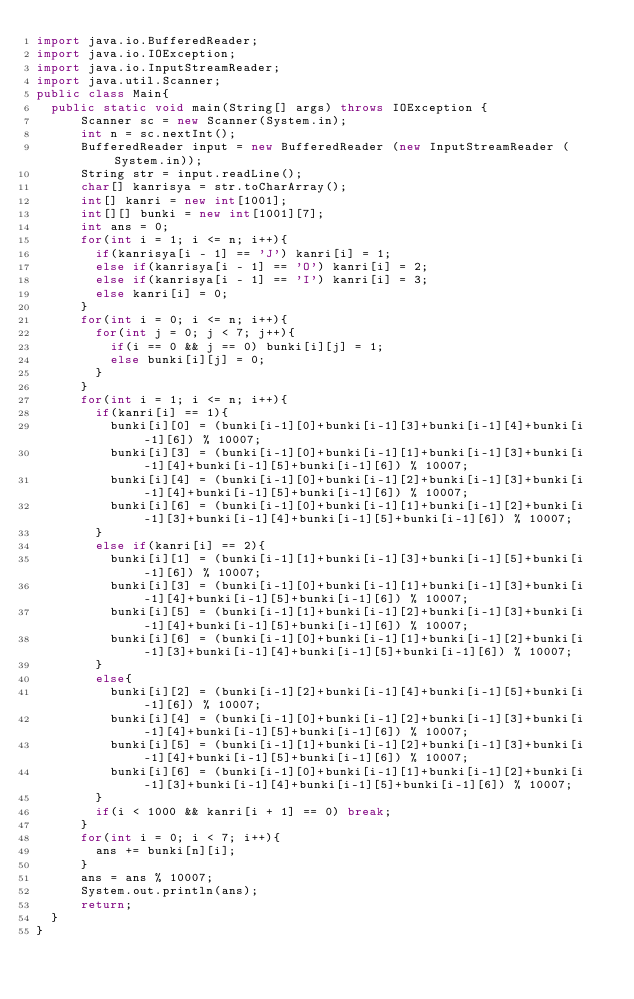<code> <loc_0><loc_0><loc_500><loc_500><_Java_>import java.io.BufferedReader;
import java.io.IOException;
import java.io.InputStreamReader;
import java.util.Scanner;
public class Main{
	public static void main(String[] args) throws IOException {
	    Scanner sc = new Scanner(System.in);
	    int n = sc.nextInt();
	    BufferedReader input = new BufferedReader (new InputStreamReader (System.in));
	    String str = input.readLine();
	    char[] kanrisya = str.toCharArray();
	    int[] kanri = new int[1001];
	    int[][] bunki = new int[1001][7];
	    int ans = 0;
	    for(int i = 1; i <= n; i++){
	    	if(kanrisya[i - 1] == 'J') kanri[i] = 1;
    		else if(kanrisya[i - 1] == 'O') kanri[i] = 2;
    		else if(kanrisya[i - 1] == 'I') kanri[i] = 3;
    		else kanri[i] = 0;
	    }
	    for(int i = 0; i <= n; i++){
	    	for(int j = 0; j < 7; j++){
	    		if(i == 0 && j == 0) bunki[i][j] = 1;
	    		else bunki[i][j] = 0;
	    	}
	    }
	    for(int i = 1; i <= n; i++){
	    	if(kanri[i] == 1){
	    		bunki[i][0] = (bunki[i-1][0]+bunki[i-1][3]+bunki[i-1][4]+bunki[i-1][6]) % 10007;
	    		bunki[i][3] = (bunki[i-1][0]+bunki[i-1][1]+bunki[i-1][3]+bunki[i-1][4]+bunki[i-1][5]+bunki[i-1][6]) % 10007;
	    		bunki[i][4] = (bunki[i-1][0]+bunki[i-1][2]+bunki[i-1][3]+bunki[i-1][4]+bunki[i-1][5]+bunki[i-1][6]) % 10007;
	    		bunki[i][6] = (bunki[i-1][0]+bunki[i-1][1]+bunki[i-1][2]+bunki[i-1][3]+bunki[i-1][4]+bunki[i-1][5]+bunki[i-1][6]) % 10007;
	    	}
	    	else if(kanri[i] == 2){
	    		bunki[i][1] = (bunki[i-1][1]+bunki[i-1][3]+bunki[i-1][5]+bunki[i-1][6]) % 10007;
	    		bunki[i][3] = (bunki[i-1][0]+bunki[i-1][1]+bunki[i-1][3]+bunki[i-1][4]+bunki[i-1][5]+bunki[i-1][6]) % 10007;
	    		bunki[i][5] = (bunki[i-1][1]+bunki[i-1][2]+bunki[i-1][3]+bunki[i-1][4]+bunki[i-1][5]+bunki[i-1][6]) % 10007;
	    		bunki[i][6] = (bunki[i-1][0]+bunki[i-1][1]+bunki[i-1][2]+bunki[i-1][3]+bunki[i-1][4]+bunki[i-1][5]+bunki[i-1][6]) % 10007;
	    	}
	    	else{
	    		bunki[i][2] = (bunki[i-1][2]+bunki[i-1][4]+bunki[i-1][5]+bunki[i-1][6]) % 10007;
	    		bunki[i][4] = (bunki[i-1][0]+bunki[i-1][2]+bunki[i-1][3]+bunki[i-1][4]+bunki[i-1][5]+bunki[i-1][6]) % 10007;
	    		bunki[i][5] = (bunki[i-1][1]+bunki[i-1][2]+bunki[i-1][3]+bunki[i-1][4]+bunki[i-1][5]+bunki[i-1][6]) % 10007;
	    		bunki[i][6] = (bunki[i-1][0]+bunki[i-1][1]+bunki[i-1][2]+bunki[i-1][3]+bunki[i-1][4]+bunki[i-1][5]+bunki[i-1][6]) % 10007;
	    	}
	    	if(i < 1000 && kanri[i + 1] == 0) break;
	    }
	    for(int i = 0; i < 7; i++){
    		ans += bunki[n][i];
    	}
	    ans = ans % 10007;
	    System.out.println(ans);
	    return;
	}
}</code> 